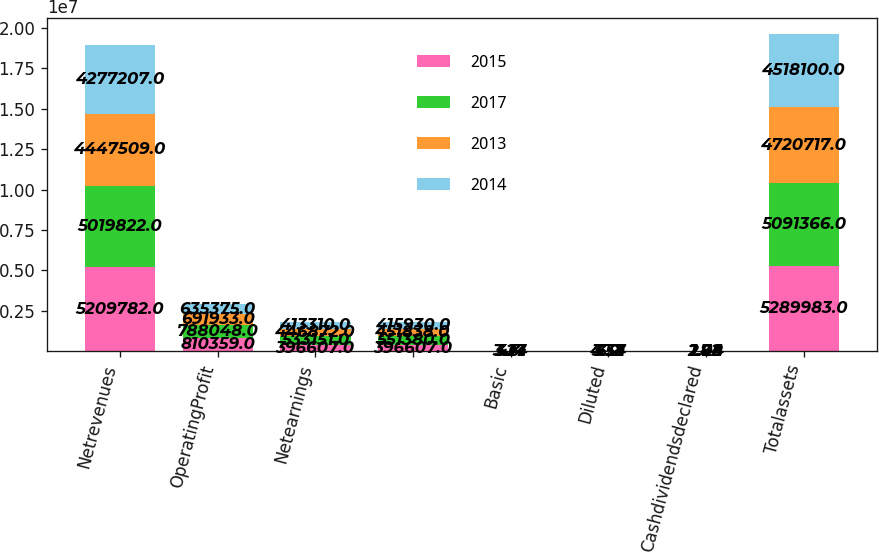Convert chart to OTSL. <chart><loc_0><loc_0><loc_500><loc_500><stacked_bar_chart><ecel><fcel>Netrevenues<fcel>OperatingProfit<fcel>Netearnings<fcel>Unnamed: 4<fcel>Basic<fcel>Diluted<fcel>Cashdividendsdeclared<fcel>Totalassets<nl><fcel>2015<fcel>5.20978e+06<fcel>810359<fcel>396607<fcel>396607<fcel>3.17<fcel>3.12<fcel>2.28<fcel>5.28998e+06<nl><fcel>2017<fcel>5.01982e+06<fcel>788048<fcel>533151<fcel>551380<fcel>4.4<fcel>4.34<fcel>2.04<fcel>5.09137e+06<nl><fcel>2013<fcel>4.44751e+06<fcel>691933<fcel>446872<fcel>451838<fcel>3.61<fcel>3.57<fcel>1.84<fcel>4.72072e+06<nl><fcel>2014<fcel>4.27721e+06<fcel>635375<fcel>413310<fcel>415930<fcel>3.24<fcel>3.2<fcel>1.72<fcel>4.5181e+06<nl></chart> 